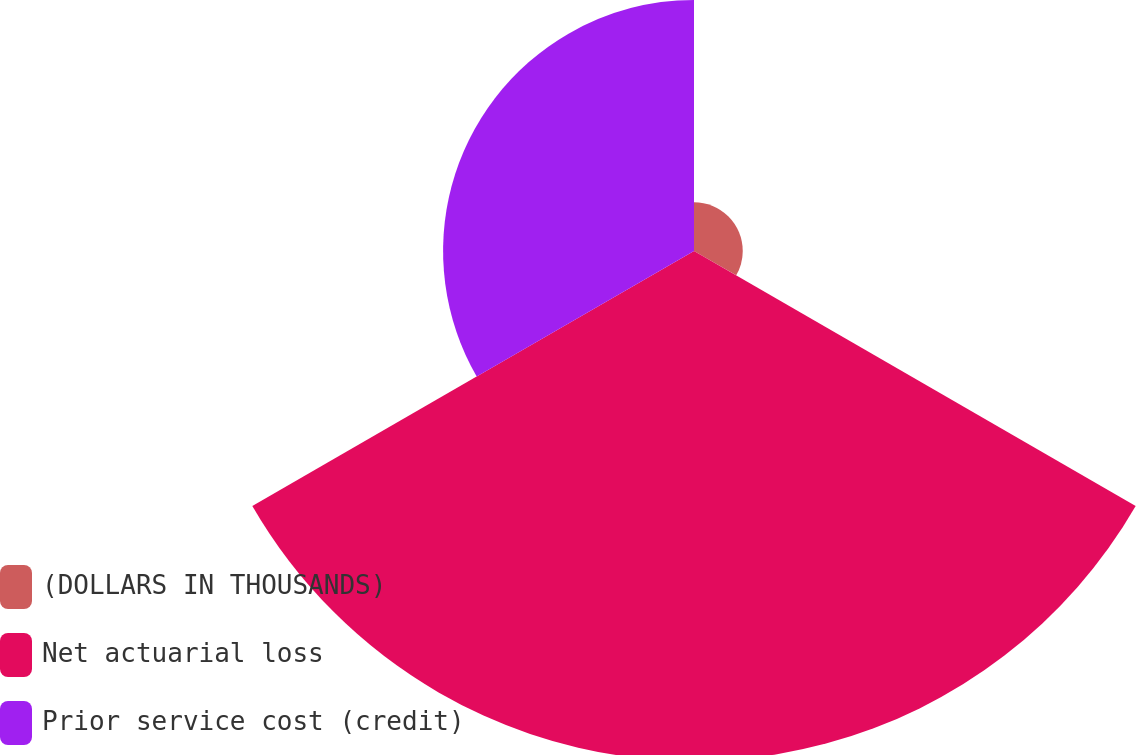Convert chart to OTSL. <chart><loc_0><loc_0><loc_500><loc_500><pie_chart><fcel>(DOLLARS IN THOUSANDS)<fcel>Net actuarial loss<fcel>Prior service cost (credit)<nl><fcel>6.02%<fcel>62.99%<fcel>30.99%<nl></chart> 